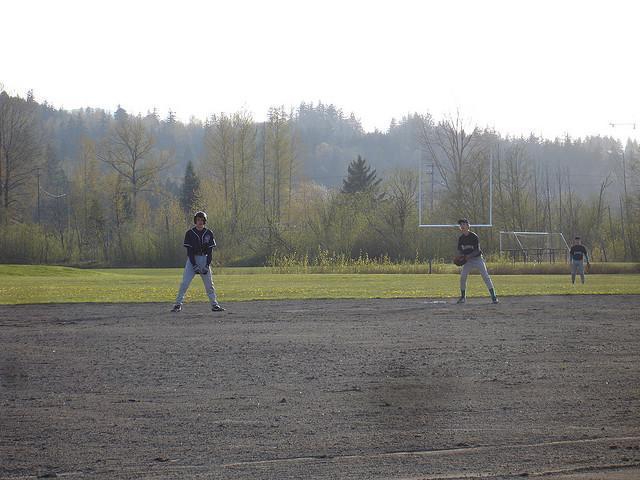How many people can be seen?
Give a very brief answer. 1. 